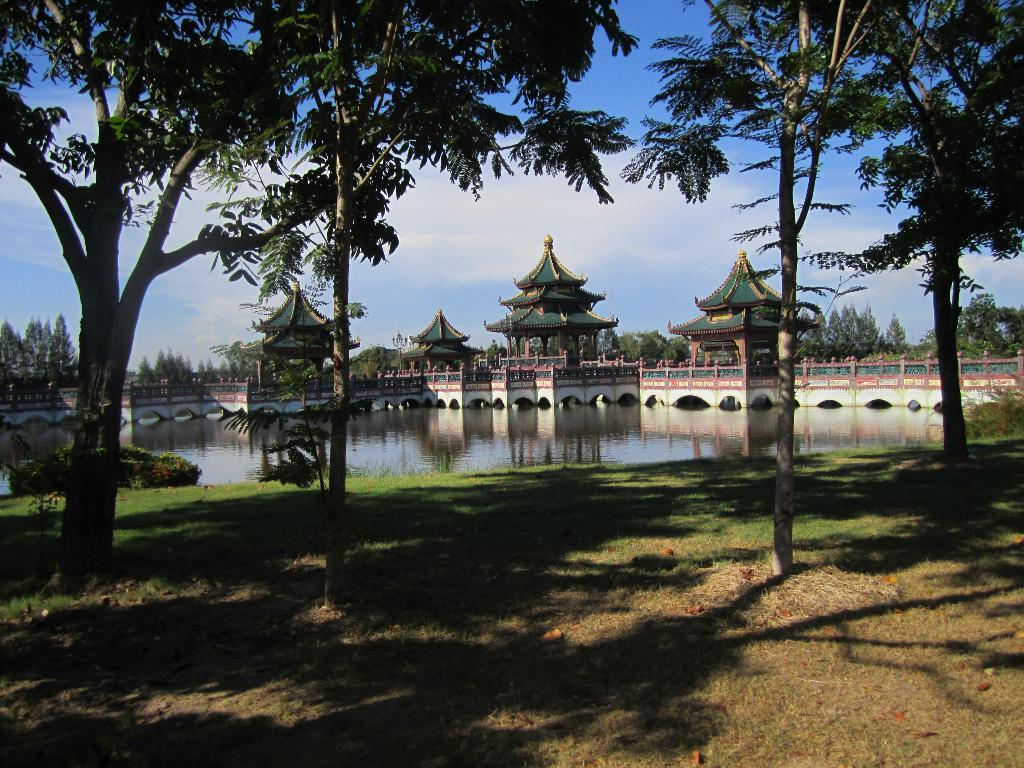What type of vegetation can be seen in the image? There are trees, grass, and plants visible in the image. What can be seen in the background of the image? Water, a wall, ancient architectures, trees, and the sky are visible in the background of the image. What is the condition of the sky in the image? The sky is visible in the background of the image, and clouds are present. What type of cushion is being used to support the stem of the tree in the image? There is no cushion or stem of a tree present in the image. What punishment is being given to the plants in the image? There is no punishment being given to the plants in the image; they are simply growing in their natural environment. 